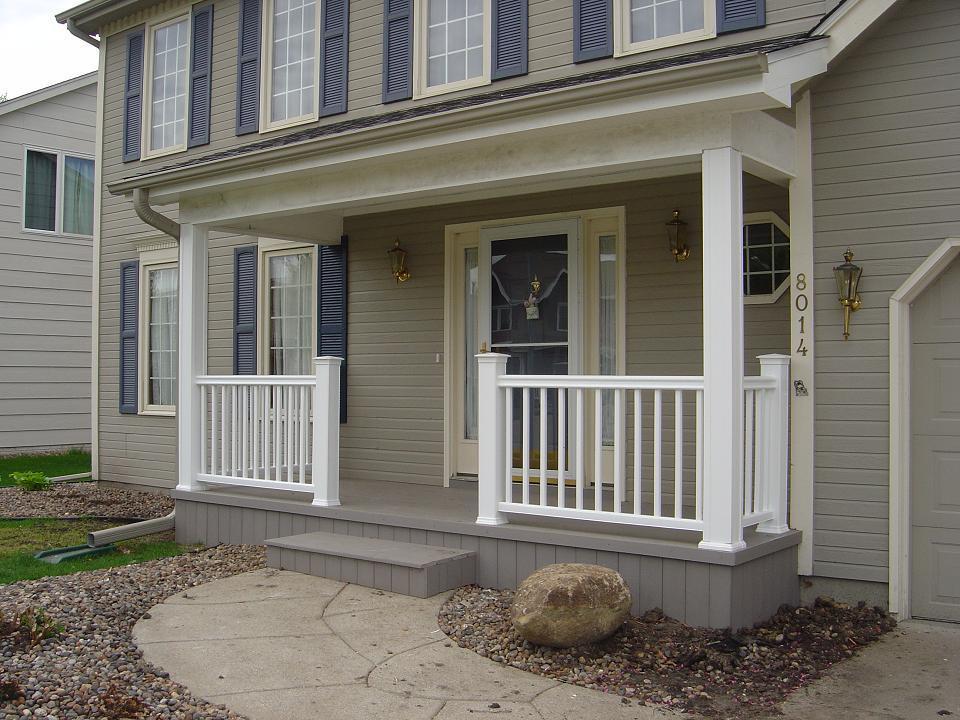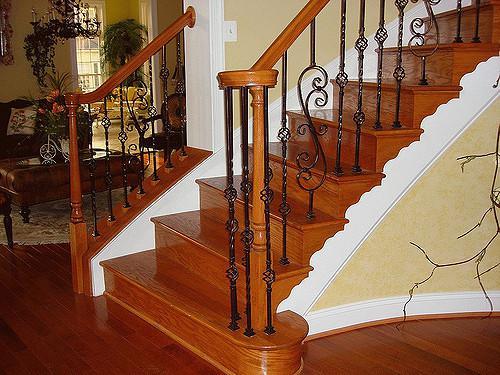The first image is the image on the left, the second image is the image on the right. Assess this claim about the two images: "The exterior of a house is shown with stairs that have very dark-colored railings.". Correct or not? Answer yes or no. No. The first image is the image on the left, the second image is the image on the right. Evaluate the accuracy of this statement regarding the images: "One of the images shows an entrance to a home and the other image shows a wooden staircase with metal balusters.". Is it true? Answer yes or no. Yes. 